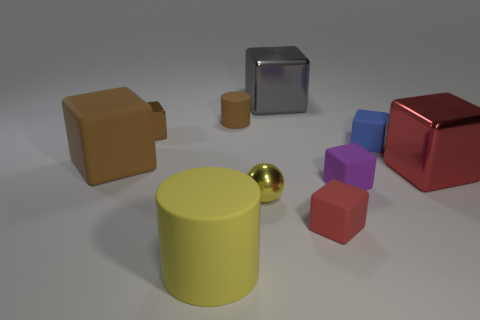Subtract all tiny purple blocks. How many blocks are left? 6 Subtract all brown cylinders. How many cylinders are left? 1 Subtract 6 cubes. How many cubes are left? 1 Subtract all cubes. How many objects are left? 3 Subtract all yellow spheres. How many red cubes are left? 2 Subtract all tiny red rubber cubes. Subtract all large brown matte cubes. How many objects are left? 8 Add 5 tiny balls. How many tiny balls are left? 6 Add 6 big gray cylinders. How many big gray cylinders exist? 6 Subtract 1 blue blocks. How many objects are left? 9 Subtract all yellow blocks. Subtract all yellow cylinders. How many blocks are left? 7 